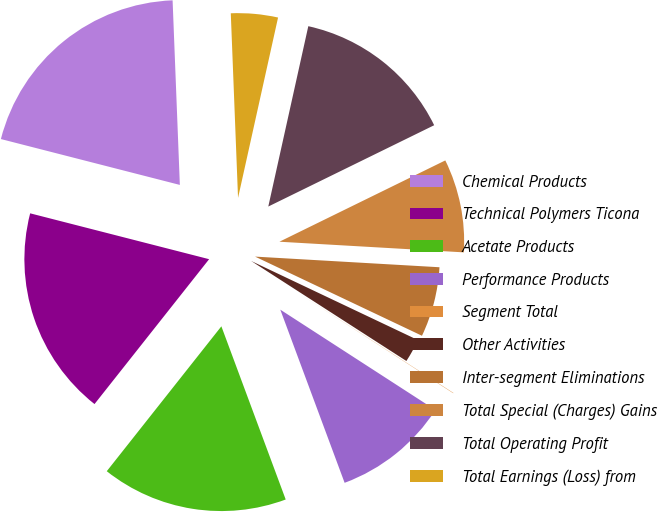Convert chart. <chart><loc_0><loc_0><loc_500><loc_500><pie_chart><fcel>Chemical Products<fcel>Technical Polymers Ticona<fcel>Acetate Products<fcel>Performance Products<fcel>Segment Total<fcel>Other Activities<fcel>Inter-segment Eliminations<fcel>Total Special (Charges) Gains<fcel>Total Operating Profit<fcel>Total Earnings (Loss) from<nl><fcel>20.38%<fcel>18.34%<fcel>16.31%<fcel>10.2%<fcel>0.03%<fcel>2.06%<fcel>6.13%<fcel>8.17%<fcel>14.27%<fcel>4.1%<nl></chart> 